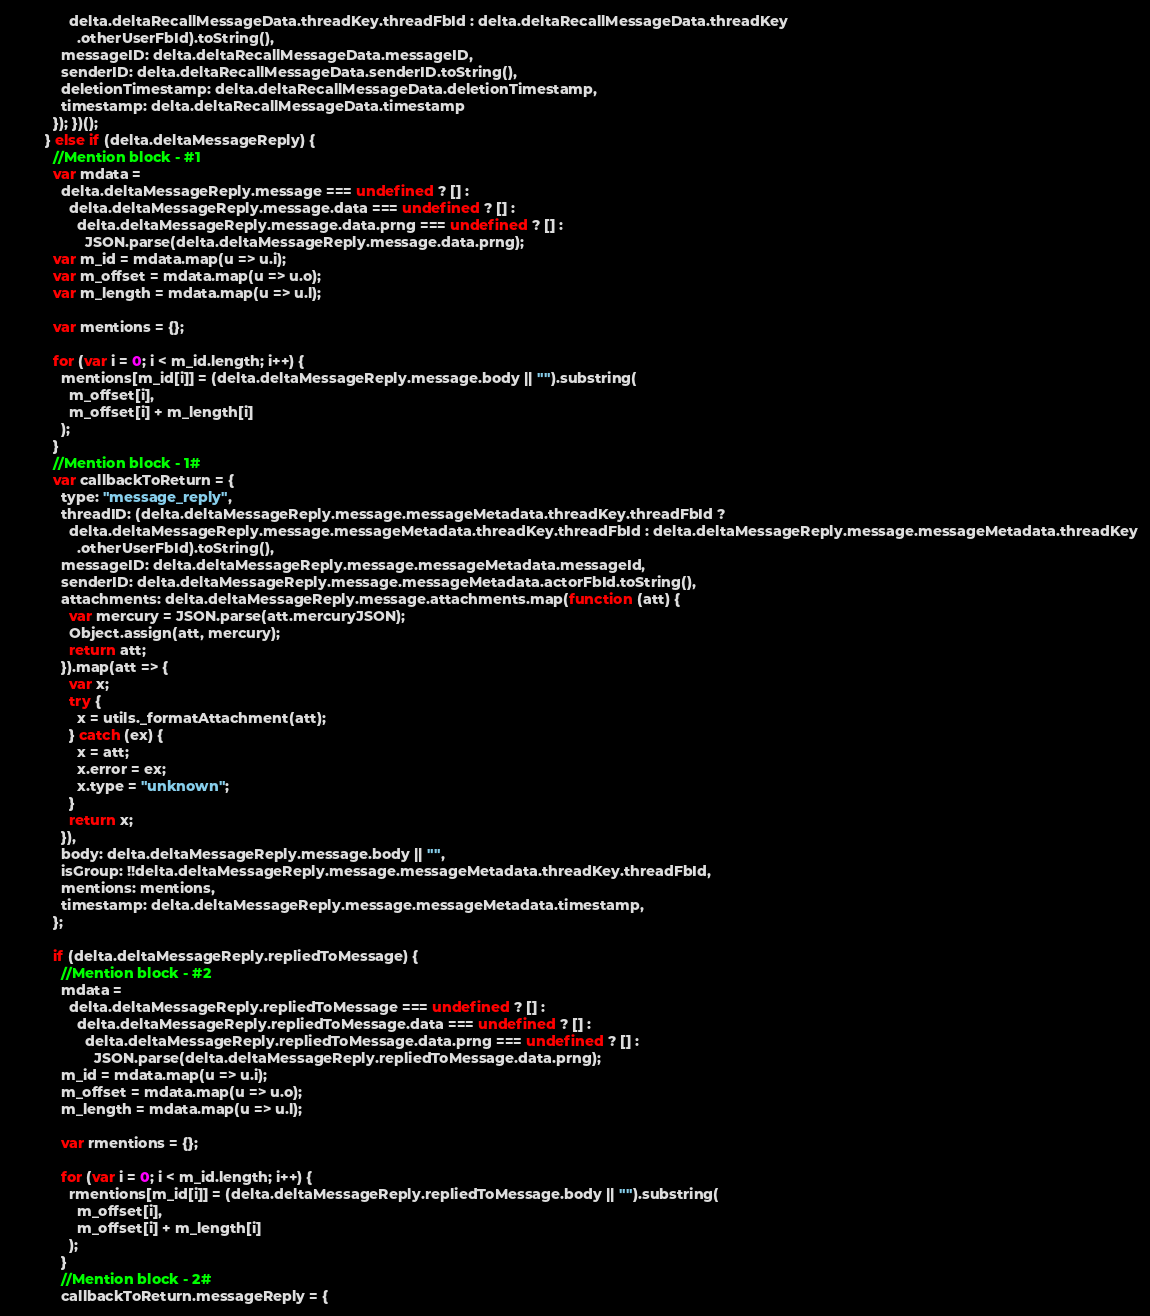Convert code to text. <code><loc_0><loc_0><loc_500><loc_500><_JavaScript_>              delta.deltaRecallMessageData.threadKey.threadFbId : delta.deltaRecallMessageData.threadKey
                .otherUserFbId).toString(),
            messageID: delta.deltaRecallMessageData.messageID,
            senderID: delta.deltaRecallMessageData.senderID.toString(),
            deletionTimestamp: delta.deltaRecallMessageData.deletionTimestamp,
            timestamp: delta.deltaRecallMessageData.timestamp
          }); })();
        } else if (delta.deltaMessageReply) {
          //Mention block - #1
          var mdata =
            delta.deltaMessageReply.message === undefined ? [] :
              delta.deltaMessageReply.message.data === undefined ? [] :
                delta.deltaMessageReply.message.data.prng === undefined ? [] :
                  JSON.parse(delta.deltaMessageReply.message.data.prng);
          var m_id = mdata.map(u => u.i);
          var m_offset = mdata.map(u => u.o);
          var m_length = mdata.map(u => u.l);

          var mentions = {};

          for (var i = 0; i < m_id.length; i++) {
            mentions[m_id[i]] = (delta.deltaMessageReply.message.body || "").substring(
              m_offset[i],
              m_offset[i] + m_length[i]
            );
          }
          //Mention block - 1#
          var callbackToReturn = {
            type: "message_reply",
            threadID: (delta.deltaMessageReply.message.messageMetadata.threadKey.threadFbId ?
              delta.deltaMessageReply.message.messageMetadata.threadKey.threadFbId : delta.deltaMessageReply.message.messageMetadata.threadKey
                .otherUserFbId).toString(),
            messageID: delta.deltaMessageReply.message.messageMetadata.messageId,
            senderID: delta.deltaMessageReply.message.messageMetadata.actorFbId.toString(),
            attachments: delta.deltaMessageReply.message.attachments.map(function (att) {
              var mercury = JSON.parse(att.mercuryJSON);
              Object.assign(att, mercury);
              return att;
            }).map(att => {
              var x;
              try {
                x = utils._formatAttachment(att);
              } catch (ex) {
                x = att;
                x.error = ex;
                x.type = "unknown";
              }
              return x;
            }),
            body: delta.deltaMessageReply.message.body || "",
            isGroup: !!delta.deltaMessageReply.message.messageMetadata.threadKey.threadFbId,
            mentions: mentions,
            timestamp: delta.deltaMessageReply.message.messageMetadata.timestamp,
          };

          if (delta.deltaMessageReply.repliedToMessage) {
            //Mention block - #2
            mdata =
              delta.deltaMessageReply.repliedToMessage === undefined ? [] :
                delta.deltaMessageReply.repliedToMessage.data === undefined ? [] :
                  delta.deltaMessageReply.repliedToMessage.data.prng === undefined ? [] :
                    JSON.parse(delta.deltaMessageReply.repliedToMessage.data.prng);
            m_id = mdata.map(u => u.i);
            m_offset = mdata.map(u => u.o);
            m_length = mdata.map(u => u.l);

            var rmentions = {};

            for (var i = 0; i < m_id.length; i++) {
              rmentions[m_id[i]] = (delta.deltaMessageReply.repliedToMessage.body || "").substring(
                m_offset[i],
                m_offset[i] + m_length[i]
              );
            }
            //Mention block - 2#
            callbackToReturn.messageReply = {</code> 